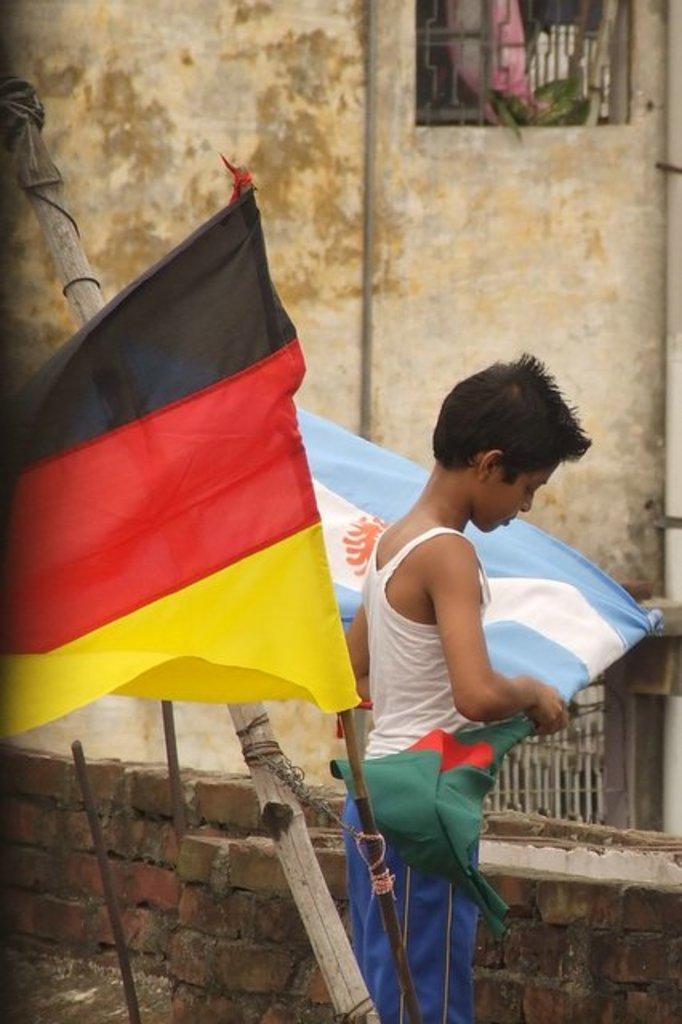Can you describe this image briefly? In this picture we can see a boy holding a flag, other flag tied to a wooden pole. In the background, we can see a brick wall and a side wall of a house. 